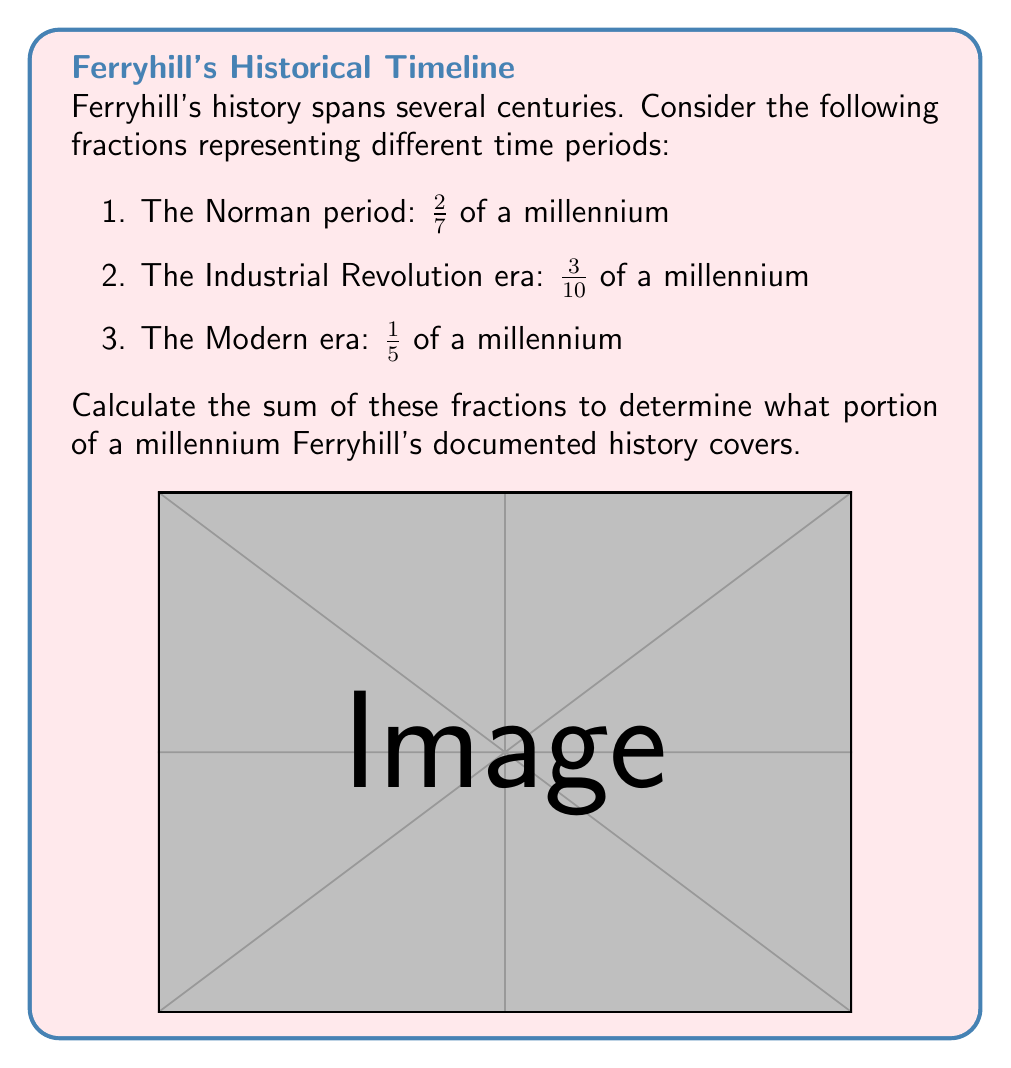Can you solve this math problem? To solve this problem, we need to add the three rational fractions. However, they have different denominators, so we need to find a common denominator first.

Step 1: Find the least common multiple (LCM) of the denominators:
LCM(7, 10, 5) = 70

Step 2: Convert each fraction to an equivalent fraction with the denominator 70:

$\frac{2}{7} = \frac{2 \times 10}{7 \times 10} = \frac{20}{70}$

$\frac{3}{10} = \frac{3 \times 7}{10 \times 7} = \frac{21}{70}$

$\frac{1}{5} = \frac{1 \times 14}{5 \times 14} = \frac{14}{70}$

Step 3: Add the numerators of the equivalent fractions:

$\frac{20}{70} + \frac{21}{70} + \frac{14}{70} = \frac{20 + 21 + 14}{70} = \frac{55}{70}$

Step 4: Simplify the fraction if possible:
$\frac{55}{70}$ can be reduced by dividing both numerator and denominator by their greatest common divisor (GCD).
GCD(55, 70) = 5

$\frac{55}{70} = \frac{55 \div 5}{70 \div 5} = \frac{11}{14}$

Therefore, the sum of the fractions representing different time periods in Ferryhill's history is $\frac{11}{14}$ of a millennium.
Answer: $\frac{11}{14}$ of a millennium 